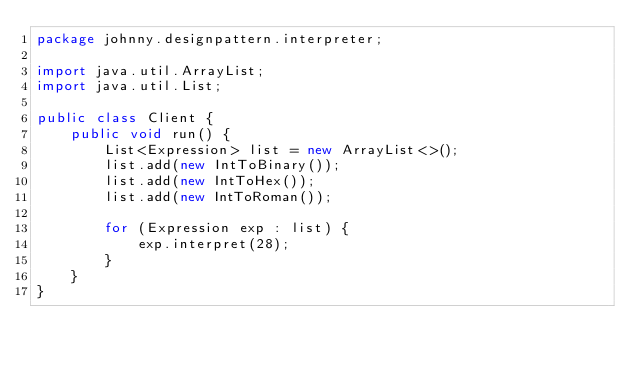Convert code to text. <code><loc_0><loc_0><loc_500><loc_500><_Java_>package johnny.designpattern.interpreter;

import java.util.ArrayList;
import java.util.List;

public class Client {
    public void run() {
        List<Expression> list = new ArrayList<>();
        list.add(new IntToBinary());
        list.add(new IntToHex());
        list.add(new IntToRoman());

        for (Expression exp : list) {
            exp.interpret(28);
        }
    }
}
</code> 